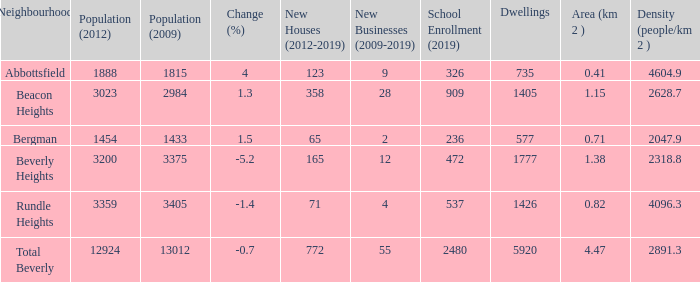In beverly heights, how many residences have a change percentage greater than -5.2? None. 